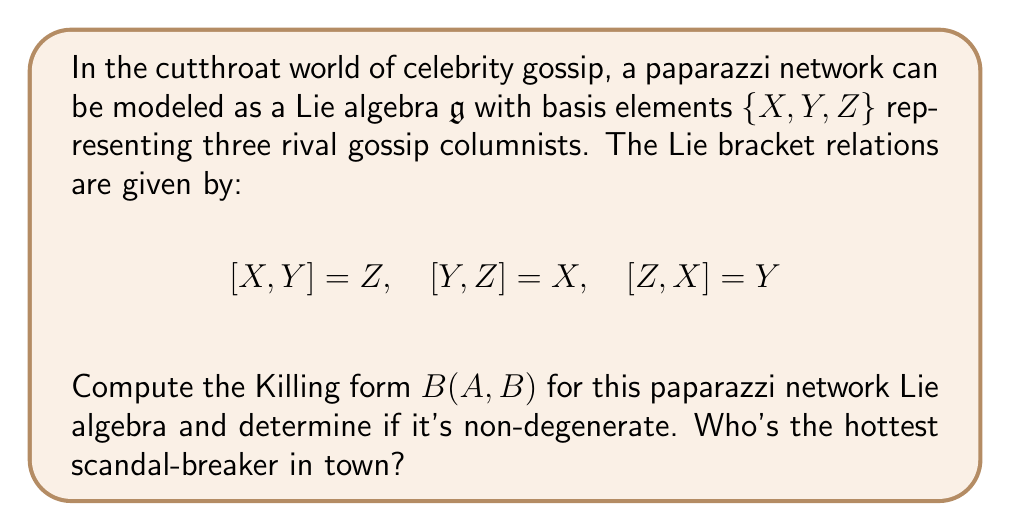Give your solution to this math problem. To compute the Killing form for this Lie algebra, we need to follow these steps:

1) The Killing form is defined as $B(A, B) = \text{tr}(\text{ad}(A) \circ \text{ad}(B))$, where $\text{ad}(A)$ is the adjoint representation of $A$.

2) First, let's compute the adjoint representations for $X$, $Y$, and $Z$:

   $\text{ad}(X) = \begin{pmatrix} 0 & 0 & -1 \\ 0 & 0 & 1 \\ 0 & -1 & 0 \end{pmatrix}$

   $\text{ad}(Y) = \begin{pmatrix} 0 & 0 & 1 \\ 0 & 0 & -1 \\ -1 & 0 & 0 \end{pmatrix}$

   $\text{ad}(Z) = \begin{pmatrix} 0 & -1 & 0 \\ 1 & 0 & 0 \\ 0 & 0 & 0 \end{pmatrix}$

3) Now, let's compute $B(X,X)$, $B(Y,Y)$, and $B(Z,Z)$:

   $B(X,X) = \text{tr}(\text{ad}(X) \circ \text{ad}(X)) = -2$
   $B(Y,Y) = \text{tr}(\text{ad}(Y) \circ \text{ad}(Y)) = -2$
   $B(Z,Z) = \text{tr}(\text{ad}(Z) \circ \text{ad}(Z)) = -2$

4) For the off-diagonal elements:

   $B(X,Y) = B(Y,X) = \text{tr}(\text{ad}(X) \circ \text{ad}(Y)) = 0$
   $B(X,Z) = B(Z,X) = \text{tr}(\text{ad}(X) \circ \text{ad}(Z)) = 0$
   $B(Y,Z) = B(Z,Y) = \text{tr}(\text{ad}(Y) \circ \text{ad}(Z)) = 0$

5) Therefore, the Killing form matrix is:

   $$B = \begin{pmatrix} -2 & 0 & 0 \\ 0 & -2 & 0 \\ 0 & 0 & -2 \end{pmatrix}$$

6) The Killing form is non-degenerate because the determinant of this matrix is non-zero: $\det(B) = -8 \neq 0$.
Answer: The Killing form for the paparazzi network Lie algebra is:

$$B = \begin{pmatrix} -2 & 0 & 0 \\ 0 & -2 & 0 \\ 0 & 0 & -2 \end{pmatrix}$$

It is non-degenerate. All three gossip columnists are equally hot scandal-breakers! 